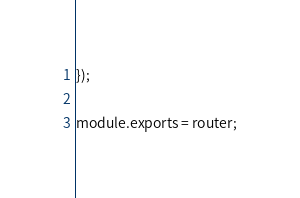Convert code to text. <code><loc_0><loc_0><loc_500><loc_500><_JavaScript_>});

module.exports = router;
</code> 